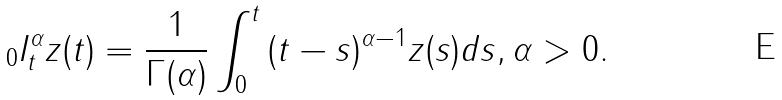Convert formula to latex. <formula><loc_0><loc_0><loc_500><loc_500>{ } _ { 0 } I ^ { \alpha } _ { t } z ( t ) = \frac { 1 } { \Gamma ( \alpha ) } \int ^ { t } _ { 0 } { ( t - s ) ^ { \alpha - 1 } z ( s ) d s } , \alpha > 0 .</formula> 